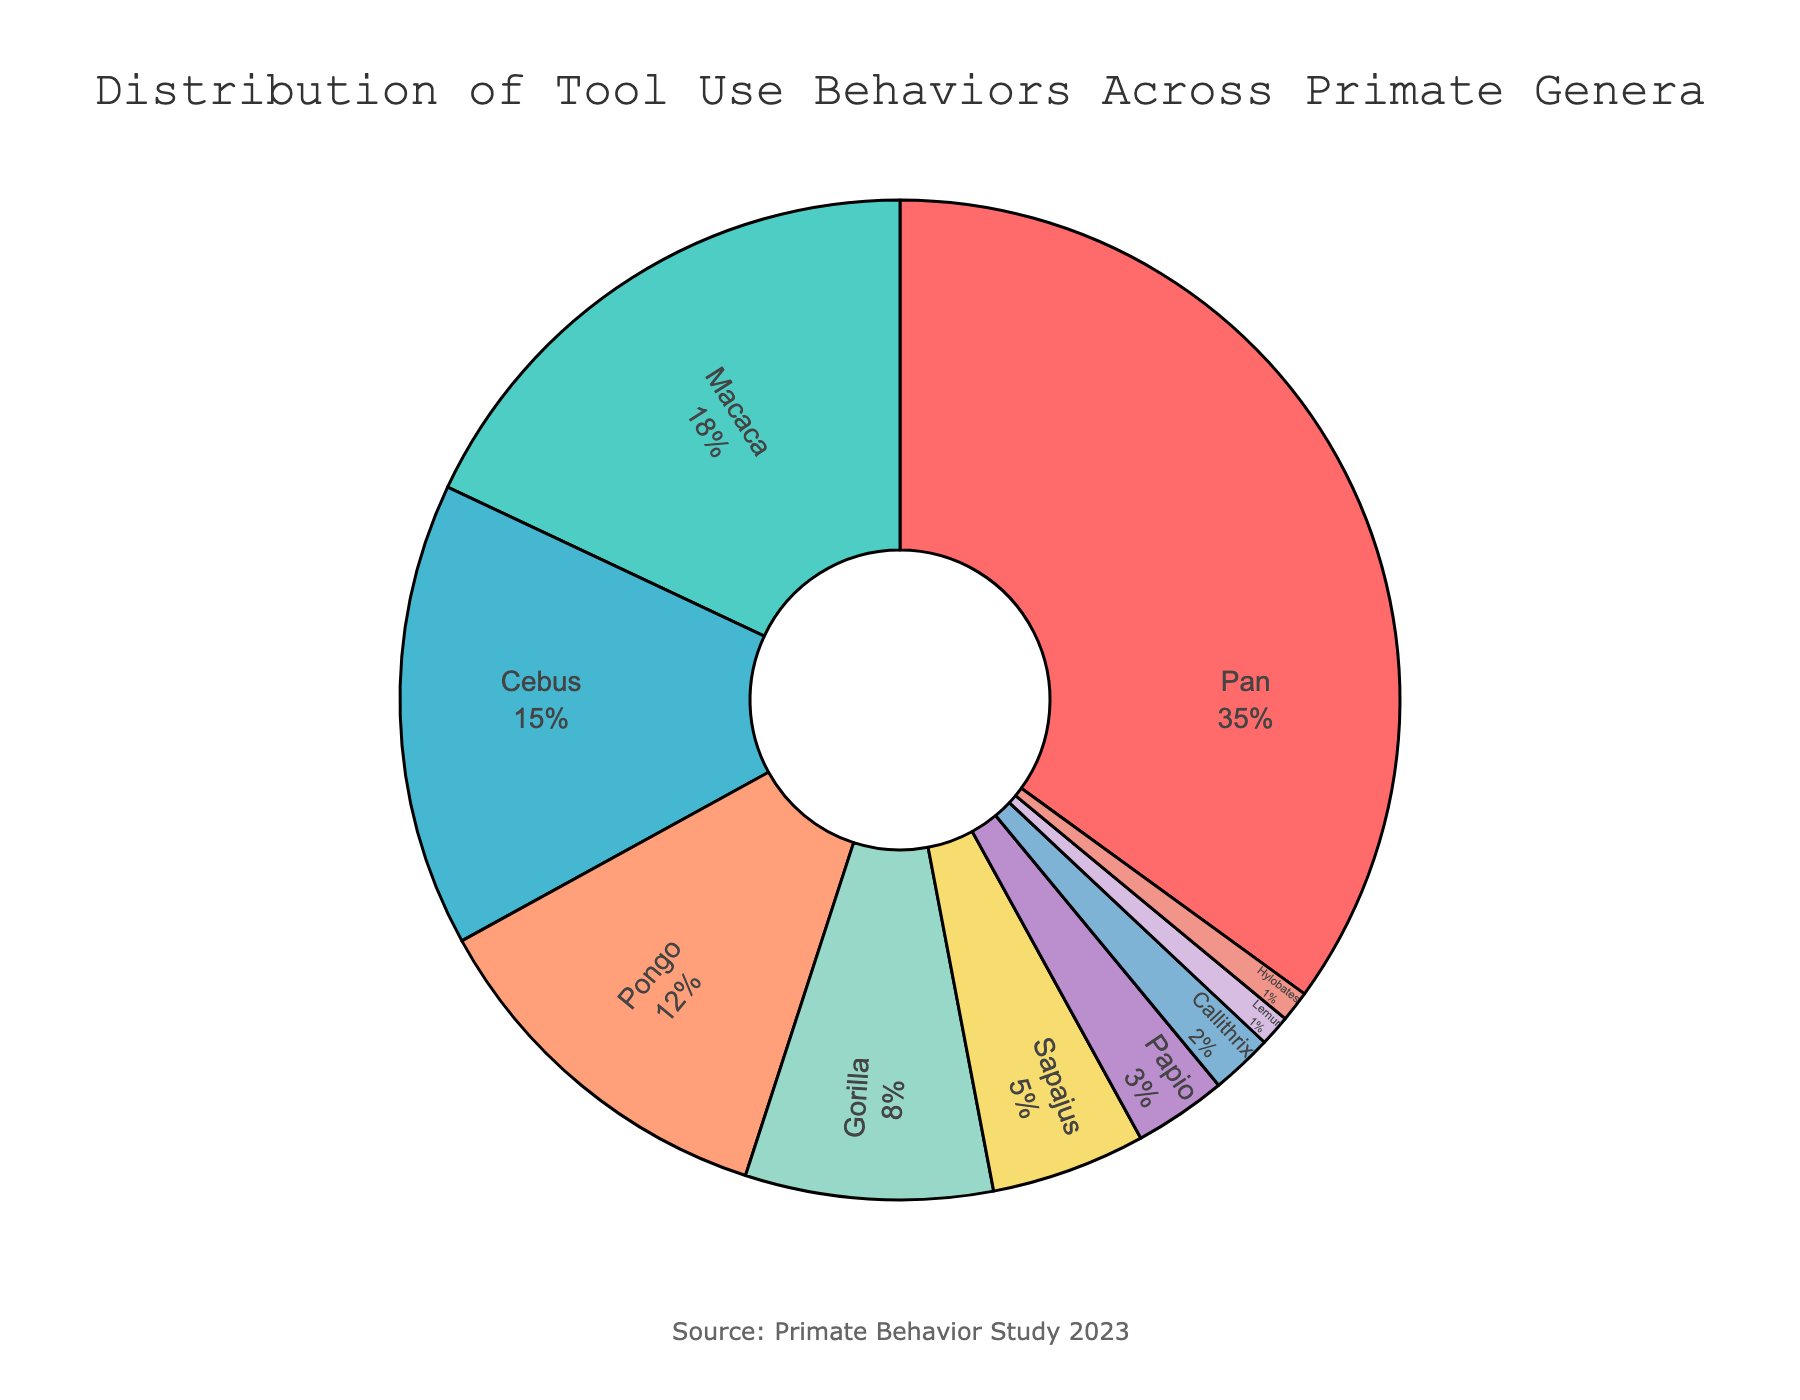What's the most dominant genus in terms of tool use? The genus with the highest percentage value represents the most dominant genus in terms of tool use. In this case, the percentage for 'Pan' is the highest at 35%.
Answer: Pan Which genus comes right after Pan in terms of tool use percentage? We need to look at the genus with the second highest percentage of tool use. ‘Macaca’ follows 'Pan' with 18% of tool use.
Answer: Macaca What percentage of tool use is contributed by Pongo and Gorilla combined? Adding the percentages of 'Pongo' (12%) and 'Gorilla' (8%) gives us 12 + 8 = 20%.
Answer: 20% Compared to Macaca, is the tool use of Cebus greater or lesser? We need to compare the percentages of 'Macaca' (18%) and 'Cebus' (15%). Since 18% is greater than 15%, Macaca has a greater tool use percentage.
Answer: Lesser Which genus contributes the smallest percentage to tool use and what is that percentage? The genus with the smallest percentage is identified visually from the chart. 'Lemur' and 'Hylobates' both contribute 1%, but no genus contributes less than that.
Answer: Lemur or Hylobates; 1% Is the sum of the tool use percentages of Sapajus, Papio, Callithrix, and Lemur less than half of the total? Adding the percentages: Sapajus (5%) + Papio (3%) + Callithrix (2%) + Lemur (1%) = 5 + 3 + 2 + 1 = 11%. Half of the total is 50%, and 11% is much less than 50%.
Answer: Yes How much more tool use percentage does Pan have compared to Pongo? Subtracting 'Pongo's' percentage (12%) from 'Pan's' percentage (35%) gives us 35 - 12 = 23%.
Answer: 23% Which color represents the genus with the smallest tool use percentage? The shade with the smallest segment in the pie chart for 'Lemur' (1%) and 'Hylobates' (1%) needs to be identified. Visually, 'Lemur' is represented by a specific color, and this information would come from the chart.
Answer: Color for Lemur/Hylobates What is the cumulative percentage of tool use for Pan, Macaca, and Cebus? Summing up the percentages of 'Pan' (35%), 'Macaca' (18%), and 'Cebus' (15%) gives us 35 + 18 + 15 = 68%.
Answer: 68% Are more than half of the tool use behaviors exhibited by Macaca and Pan combined? Sum the percentages of 'Pan' (35%) and 'Macaca' (18%), then compare to 50%. 35 + 18 = 53%, which is more than 50%.
Answer: Yes 